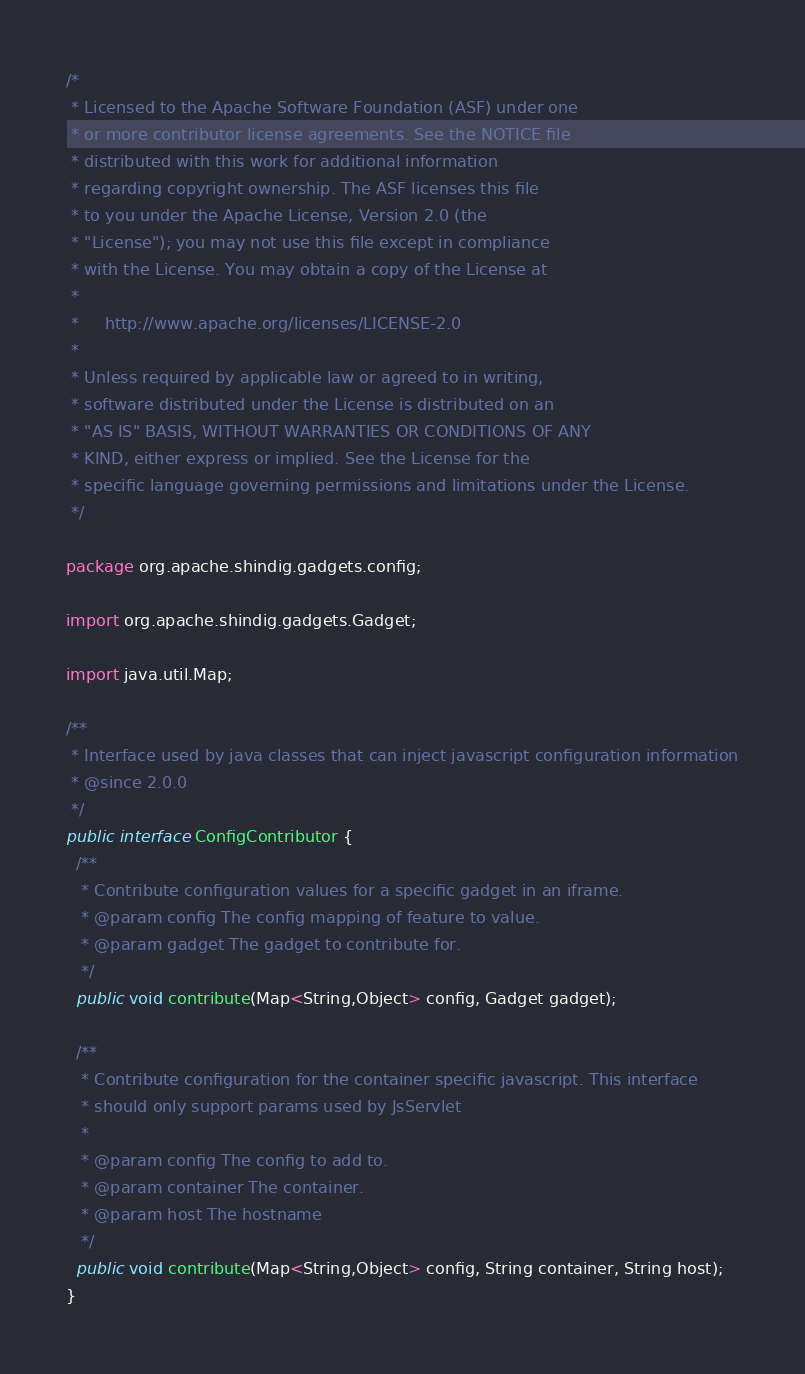Convert code to text. <code><loc_0><loc_0><loc_500><loc_500><_Java_>/*
 * Licensed to the Apache Software Foundation (ASF) under one
 * or more contributor license agreements. See the NOTICE file
 * distributed with this work for additional information
 * regarding copyright ownership. The ASF licenses this file
 * to you under the Apache License, Version 2.0 (the
 * "License"); you may not use this file except in compliance
 * with the License. You may obtain a copy of the License at
 *
 *     http://www.apache.org/licenses/LICENSE-2.0
 *
 * Unless required by applicable law or agreed to in writing,
 * software distributed under the License is distributed on an
 * "AS IS" BASIS, WITHOUT WARRANTIES OR CONDITIONS OF ANY
 * KIND, either express or implied. See the License for the
 * specific language governing permissions and limitations under the License.
 */

package org.apache.shindig.gadgets.config;

import org.apache.shindig.gadgets.Gadget;

import java.util.Map;

/**
 * Interface used by java classes that can inject javascript configuration information
 * @since 2.0.0
 */
public interface ConfigContributor {
  /**
   * Contribute configuration values for a specific gadget in an iframe.
   * @param config The config mapping of feature to value.
   * @param gadget The gadget to contribute for.
   */
  public void contribute(Map<String,Object> config, Gadget gadget);

  /**
   * Contribute configuration for the container specific javascript. This interface
   * should only support params used by JsServlet
   *
   * @param config The config to add to.
   * @param container The container.
   * @param host The hostname
   */
  public void contribute(Map<String,Object> config, String container, String host);
}
</code> 